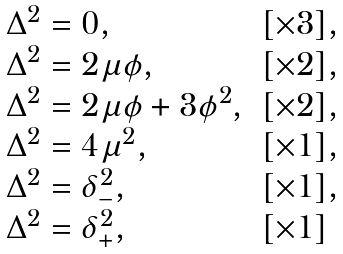Convert formula to latex. <formula><loc_0><loc_0><loc_500><loc_500>\begin{array} { l l } \Delta ^ { 2 } = 0 , & [ \times 3 ] , \\ \Delta ^ { 2 } = 2 \mu \phi , & [ \times 2 ] , \\ \Delta ^ { 2 } = 2 \mu \phi + 3 \phi ^ { 2 } , & [ \times 2 ] , \\ \Delta ^ { 2 } = 4 \mu ^ { 2 } , & [ \times 1 ] , \\ \Delta ^ { 2 } = \delta _ { - } ^ { 2 } , & [ \times 1 ] , \\ \Delta ^ { 2 } = \delta _ { + } ^ { 2 } , & [ \times 1 ] \end{array}</formula> 